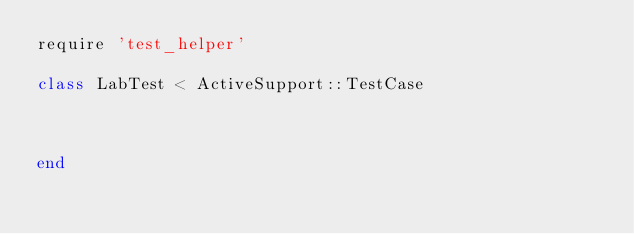<code> <loc_0><loc_0><loc_500><loc_500><_Ruby_>require 'test_helper'

class LabTest < ActiveSupport::TestCase



end
</code> 